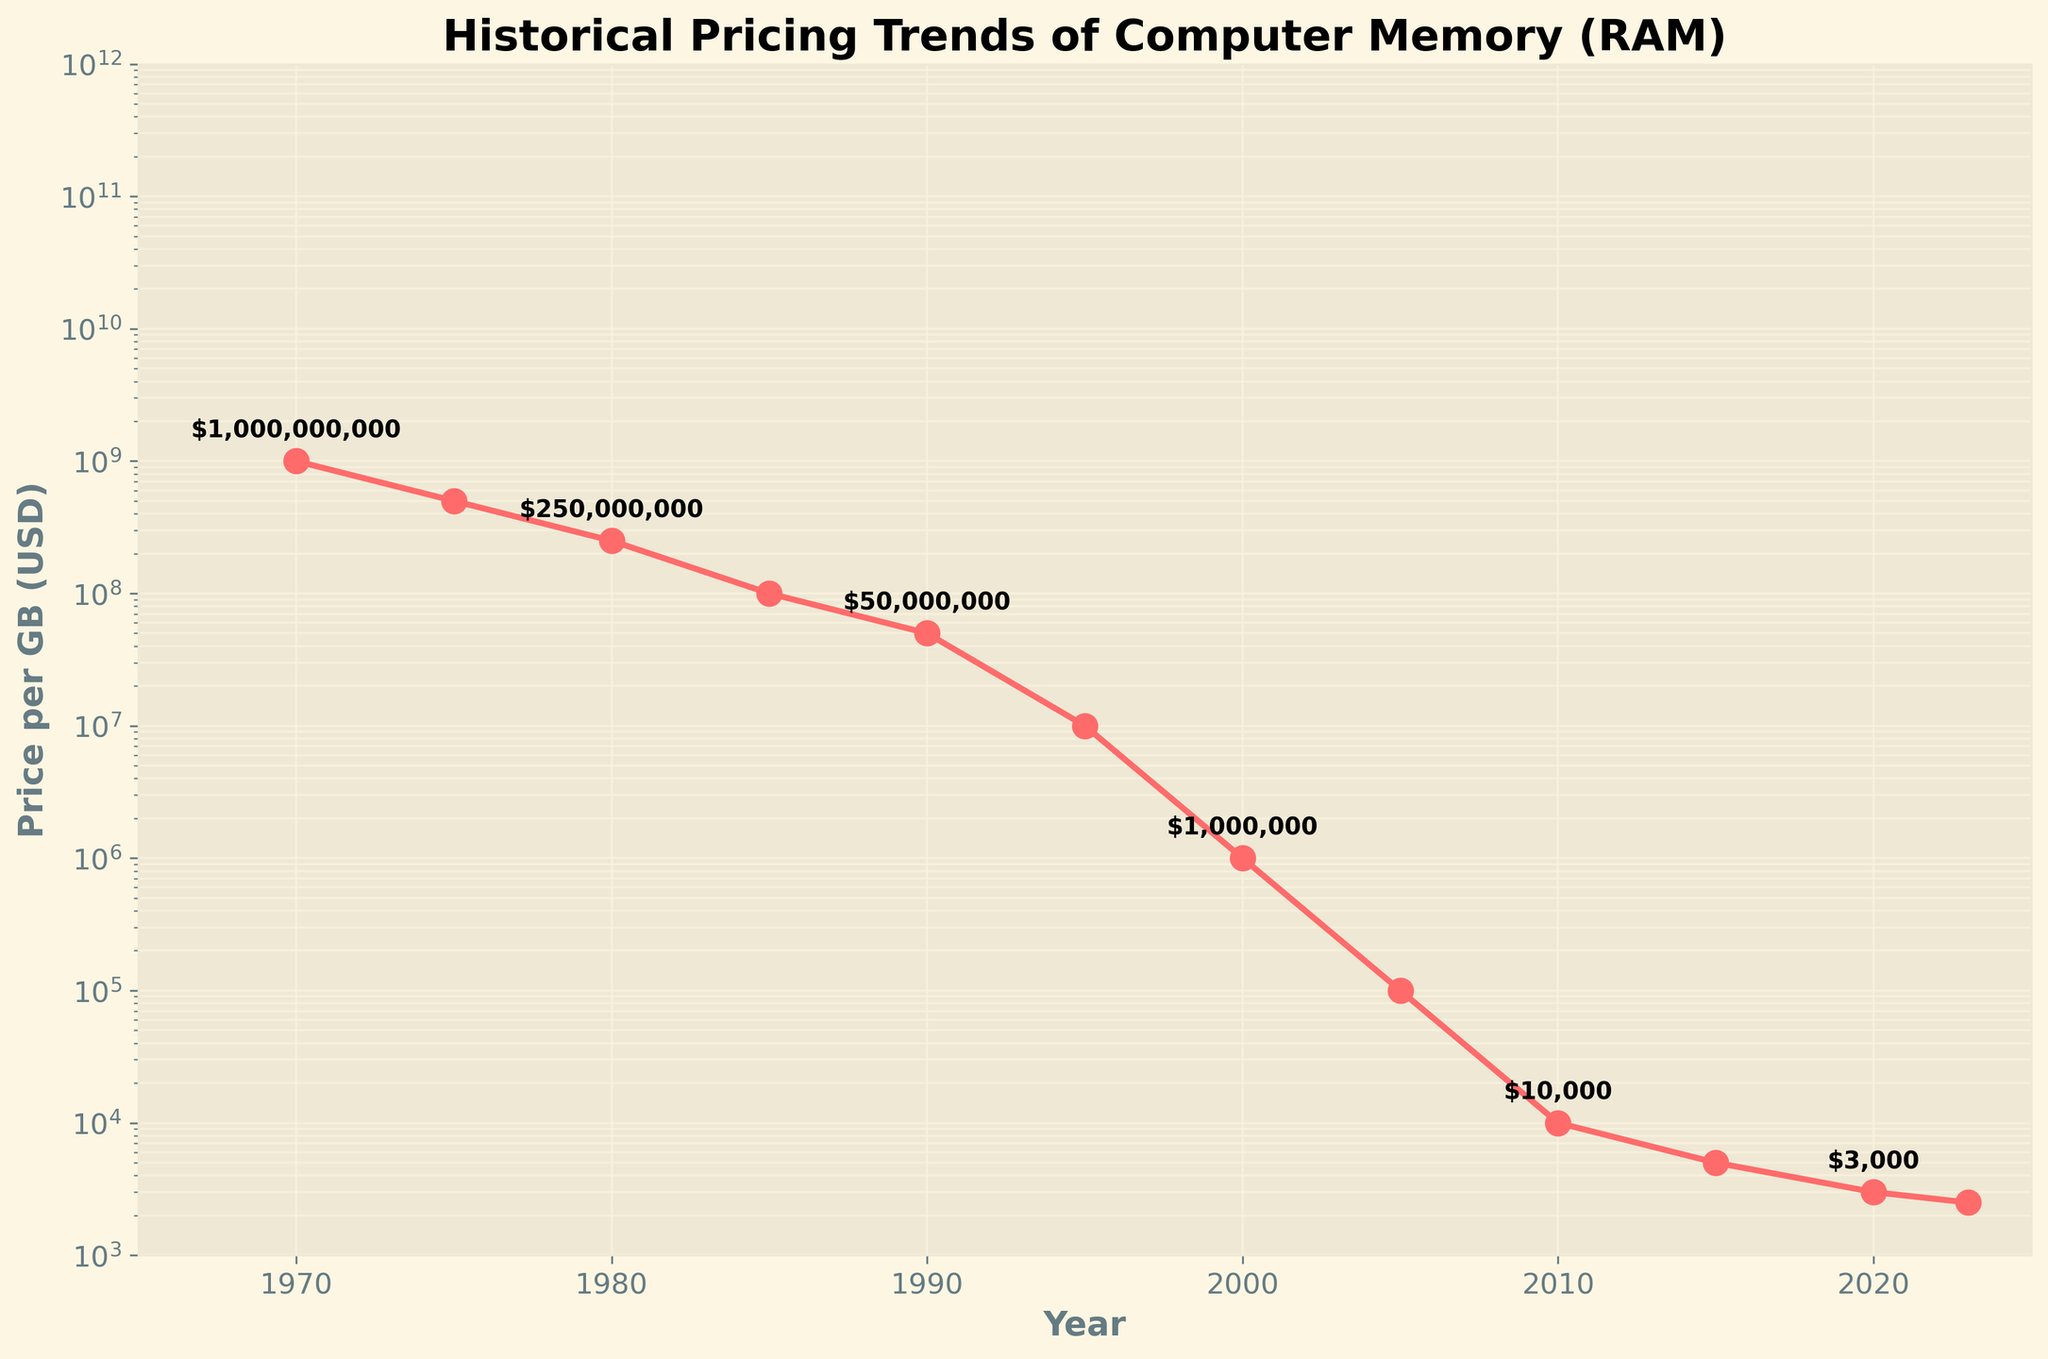How many times did the price of RAM per GB drop by half between 1970 and 1980? In 1970, the price was $1,000,000,000, and in 1980, it was $250,000,000. A drop by half would follow the sequence: $1,000,000,000 -> $500,000,000 -> $250,000,000. This represents two halving events.
Answer: 2 In which decade did the most significant drop in price per GB of RAM occur? By examining the figure, the largest decrease in price per GB of RAM seems to occur between 1980 and 1990, where the price dropped from $250,000,000 to $50,000,000.
Answer: 1980s What is the approximate percentage decrease in the price per GB of RAM from 1975 to 1980? In 1975, the price was $500,000,000, and in 1980, it was $250,000,000. The percentage decrease is: ((500,000,000 - 250,000,000) / 500,000,000) * 100 = 50%.
Answer: 50% What is the price per GB of RAM in 2015? According to the figure, the price of RAM per GB in 2015 is labeled as $5,000.
Answer: $5,000 By how much did the price per GB of RAM decrease from 2000 to 2010? In 2000, the price was $1,000,000, and in 2010, it was $10,000. The decrease is $1,000,000 - $10,000 = $990,000.
Answer: $990,000 Is the price per GB of RAM in 2023 less than or equal to the price in 2020? The figure shows that the price in 2023 is labeled as $2,500, while in 2020, it is labeled as $3,000. Thus, the price in 2023 is less than the price in 2020.
Answer: Yes What trend is shown by the plot in terms of the price of RAM per GB from 1970 to 2023? The plot shows a consistent downward trend in the price of RAM per GB from 1970 to 2023, indicating a significant drop in prices over the years.
Answer: Downward trend Compare the price per GB of RAM in 1995 and 2010. Which year had a lower price? In 1995, the price was $10,000,000, and in 2010, it was $10,000. Comparing these values, 2010 had a lower price.
Answer: 2010 How does the trend in RAM prices align with advancements in technology over time? The significant decrease in price per GB of RAM aligns with many technological advancements, such as increased production efficiency, advances in semiconductor fabrication, and economies of scale. This supports the observed trend of decreasing memory costs over the decades.
Answer: Technological advancements have driven the decrease in prices 